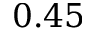<formula> <loc_0><loc_0><loc_500><loc_500>0 . 4 5</formula> 